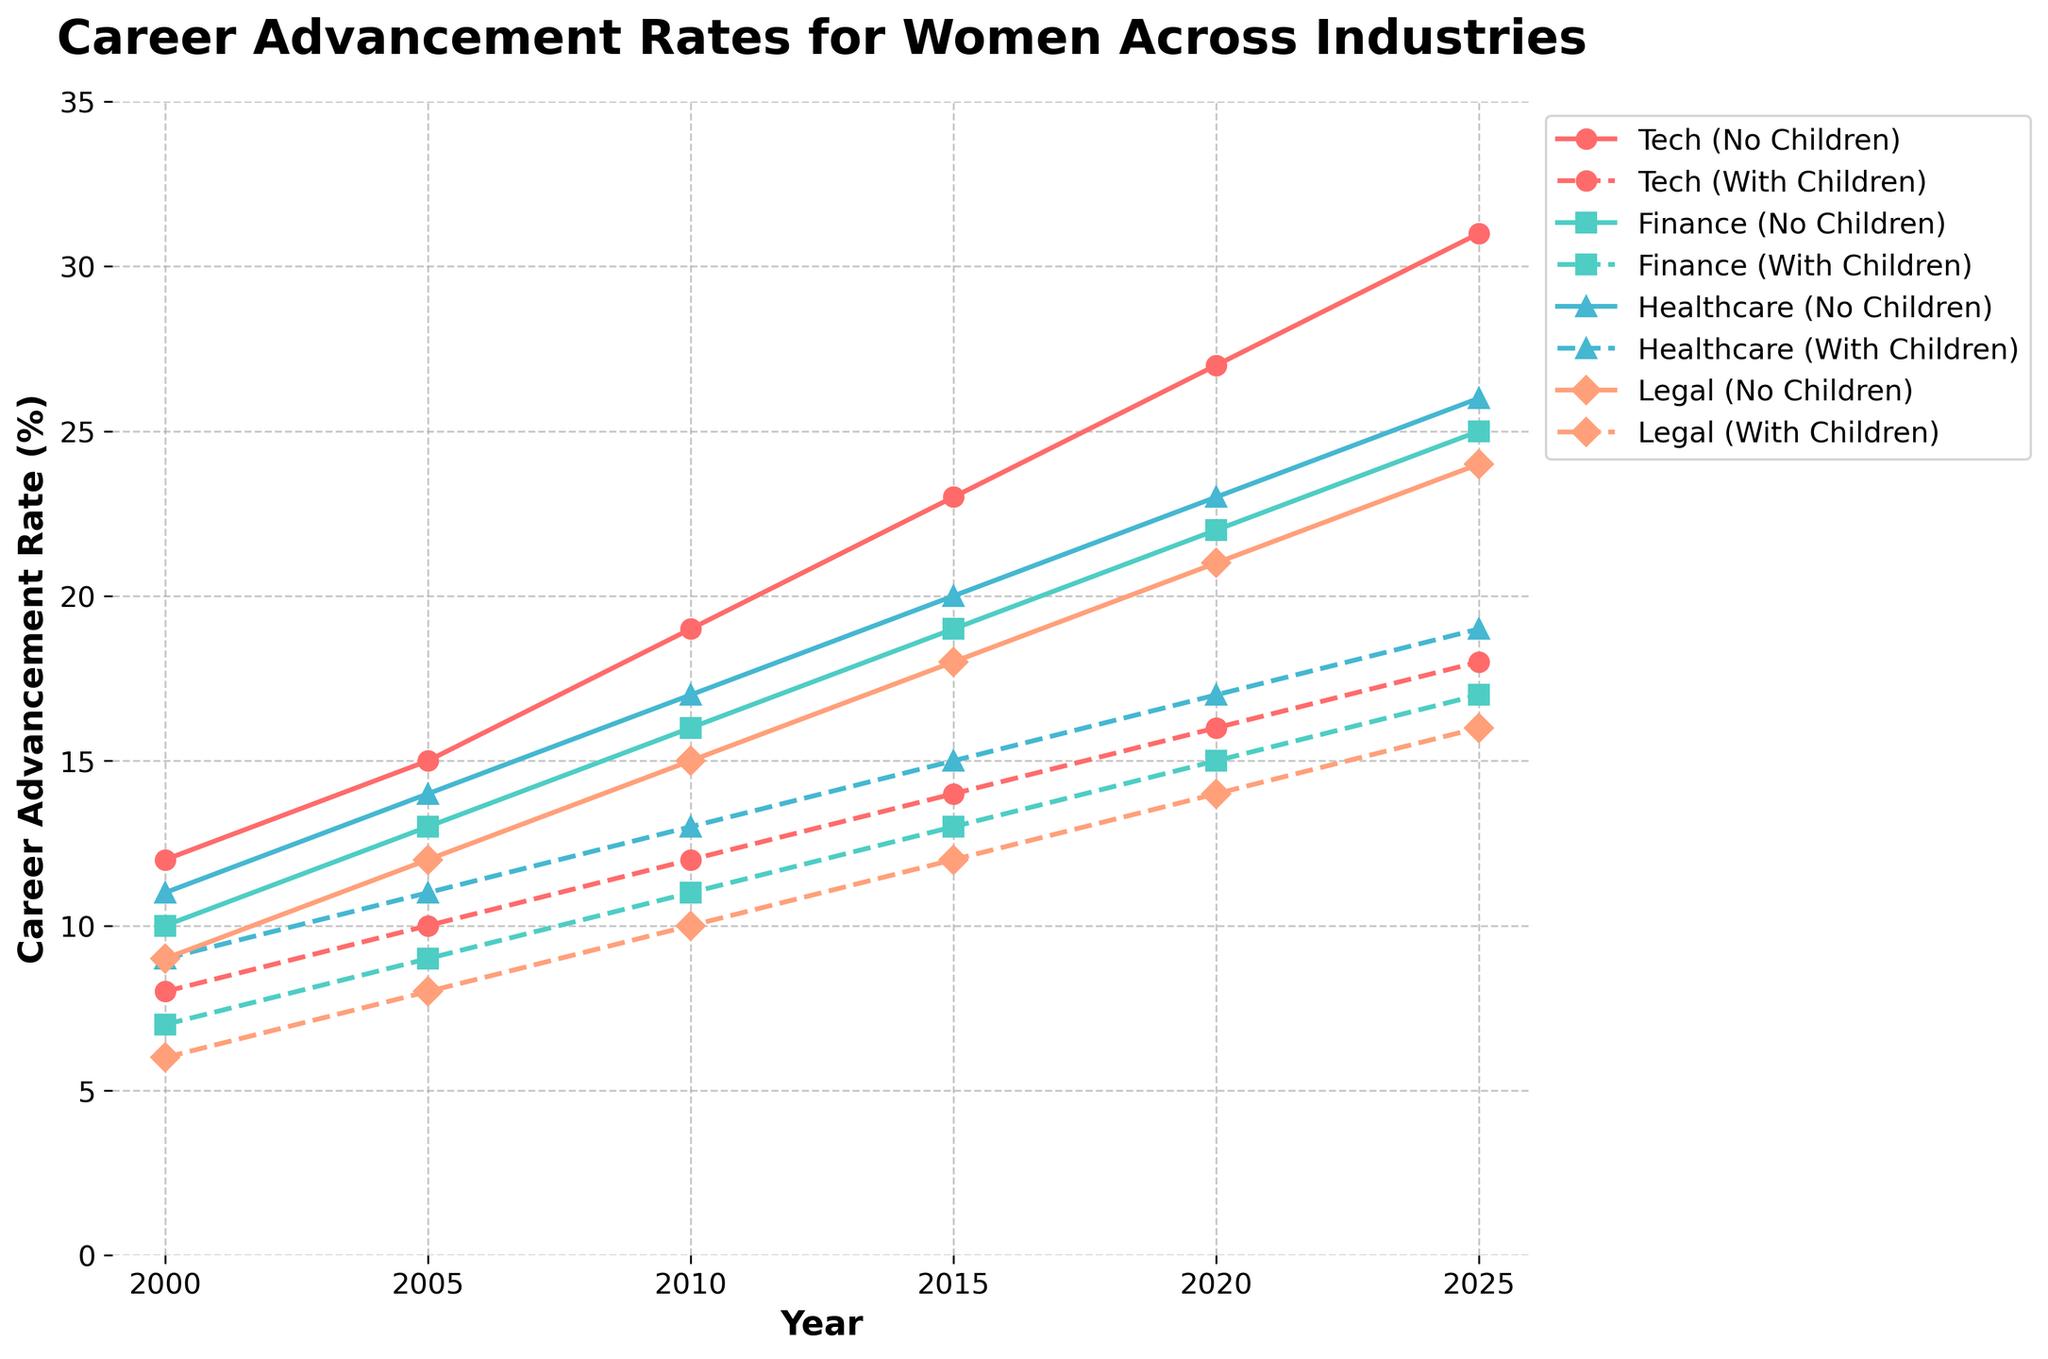What is the highest career advancement rate achieved by women without children in the Tech industry? To find the highest career advancement rate for women without children in the Tech industry, look at the line labeled "Tech (No Children)" and identify the maximum value it reaches. This occurs in the year 2025 at a rate of 31%.
Answer: 31% Which industry showed the smallest difference in career advancement rates between women with and without children in the year 2020? To find this, take the difference between the rates of women with and without children for each industry in 2020: Tech (27%-16%=11%), Finance (22%-15%=7%), Healthcare (23%-17%=6%), and Legal (21%-14%=7%). The smallest difference is in Healthcare with 6%.
Answer: Healthcare What is the average career advancement rate for women with children in the Finance industry between 2000 and 2025? To find the average rate, sum the values for the given years and divide by the number of years: (7+9+11+13+15+17) = 72; 72 divided by 6 (number of years) = 12.
Answer: 12 Between 2005 and 2015, by how much did the career advancement rate for women without children in the Healthcare industry increase? Calculate the difference between the values in 2015 and 2005 for Healthcare (No Children). In 2015, it was 20% and in 2005, it was 14%. The increase is 20% - 14% = 6%.
Answer: 6% In which year did women with children in the Legal industry show the greatest career advancement rate among all years displayed? Look at the values for "Legal (With Children)" across the timeline. The highest value is 16% in the year 2025.
Answer: 2025 Which industry had the greatest overall growth in career advancement rate for women without children from 2000 to 2025? Calculate the change for each industry from 2000 to 2025. 
Tech: 31%-12% = 19%
Finance: 25%-10% = 15%
Healthcare: 26%-11% = 15%
Legal: 24%-9% = 15%
Tech had the greatest overall growth of 19%.
Answer: Tech By how much did the career advancement rate for women with children in the Tech industry increase from 2000 to 2025? Calculate the difference between the values in 2025 and 2000 for Tech (With Children): 18% - 8% = 10%.
Answer: 10% Compare the career advancement rate for women with children in the Finance industry in 2010 with the rate for women without children in the Legal industry in the same year. Which is higher? Look at the values for "Finance (With Children)" and "Legal (No Children)" in 2010. Finance (With Children) is 11% and Legal (No Children) is 15%. The rate is higher for women without children in the Legal industry, 15% > 11%.
Answer: Legal (No Children) What is the difference in career advancement rates for women with and without children in the Healthcare industry in 2025? Subtract the rate for "Healthcare (With Children)" from "Healthcare (No Children)" in 2025: 26% - 19% = 7%.
Answer: 7% 